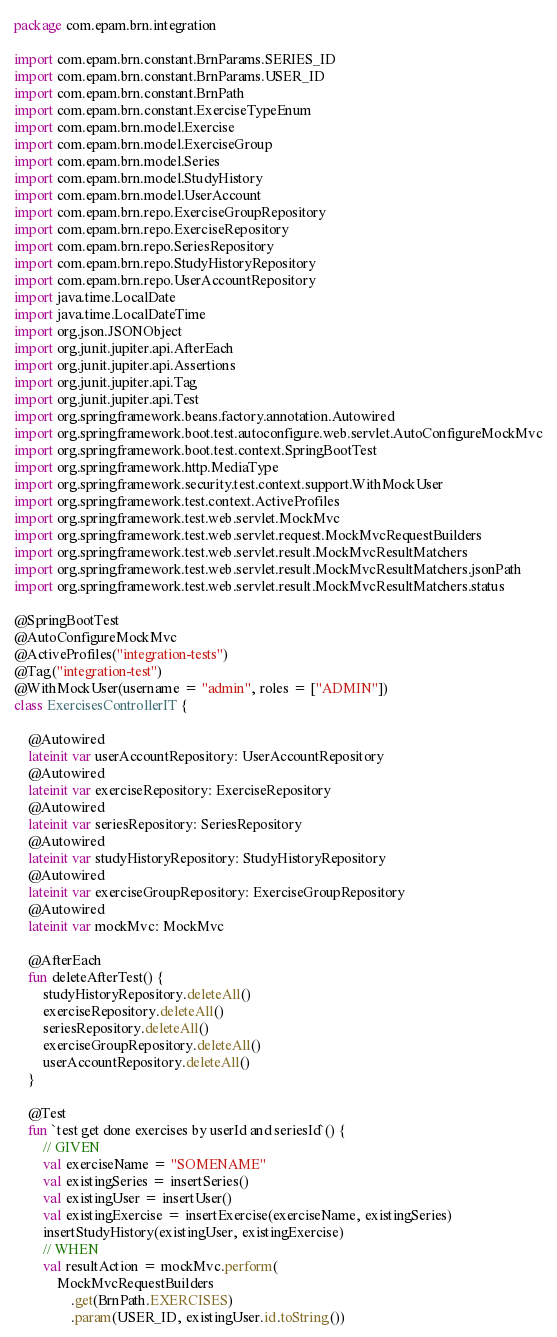Convert code to text. <code><loc_0><loc_0><loc_500><loc_500><_Kotlin_>package com.epam.brn.integration

import com.epam.brn.constant.BrnParams.SERIES_ID
import com.epam.brn.constant.BrnParams.USER_ID
import com.epam.brn.constant.BrnPath
import com.epam.brn.constant.ExerciseTypeEnum
import com.epam.brn.model.Exercise
import com.epam.brn.model.ExerciseGroup
import com.epam.brn.model.Series
import com.epam.brn.model.StudyHistory
import com.epam.brn.model.UserAccount
import com.epam.brn.repo.ExerciseGroupRepository
import com.epam.brn.repo.ExerciseRepository
import com.epam.brn.repo.SeriesRepository
import com.epam.brn.repo.StudyHistoryRepository
import com.epam.brn.repo.UserAccountRepository
import java.time.LocalDate
import java.time.LocalDateTime
import org.json.JSONObject
import org.junit.jupiter.api.AfterEach
import org.junit.jupiter.api.Assertions
import org.junit.jupiter.api.Tag
import org.junit.jupiter.api.Test
import org.springframework.beans.factory.annotation.Autowired
import org.springframework.boot.test.autoconfigure.web.servlet.AutoConfigureMockMvc
import org.springframework.boot.test.context.SpringBootTest
import org.springframework.http.MediaType
import org.springframework.security.test.context.support.WithMockUser
import org.springframework.test.context.ActiveProfiles
import org.springframework.test.web.servlet.MockMvc
import org.springframework.test.web.servlet.request.MockMvcRequestBuilders
import org.springframework.test.web.servlet.result.MockMvcResultMatchers
import org.springframework.test.web.servlet.result.MockMvcResultMatchers.jsonPath
import org.springframework.test.web.servlet.result.MockMvcResultMatchers.status

@SpringBootTest
@AutoConfigureMockMvc
@ActiveProfiles("integration-tests")
@Tag("integration-test")
@WithMockUser(username = "admin", roles = ["ADMIN"])
class ExercisesControllerIT {

    @Autowired
    lateinit var userAccountRepository: UserAccountRepository
    @Autowired
    lateinit var exerciseRepository: ExerciseRepository
    @Autowired
    lateinit var seriesRepository: SeriesRepository
    @Autowired
    lateinit var studyHistoryRepository: StudyHistoryRepository
    @Autowired
    lateinit var exerciseGroupRepository: ExerciseGroupRepository
    @Autowired
    lateinit var mockMvc: MockMvc

    @AfterEach
    fun deleteAfterTest() {
        studyHistoryRepository.deleteAll()
        exerciseRepository.deleteAll()
        seriesRepository.deleteAll()
        exerciseGroupRepository.deleteAll()
        userAccountRepository.deleteAll()
    }

    @Test
    fun `test get done exercises by userId and seriesId`() {
        // GIVEN
        val exerciseName = "SOMENAME"
        val existingSeries = insertSeries()
        val existingUser = insertUser()
        val existingExercise = insertExercise(exerciseName, existingSeries)
        insertStudyHistory(existingUser, existingExercise)
        // WHEN
        val resultAction = mockMvc.perform(
            MockMvcRequestBuilders
                .get(BrnPath.EXERCISES)
                .param(USER_ID, existingUser.id.toString())</code> 